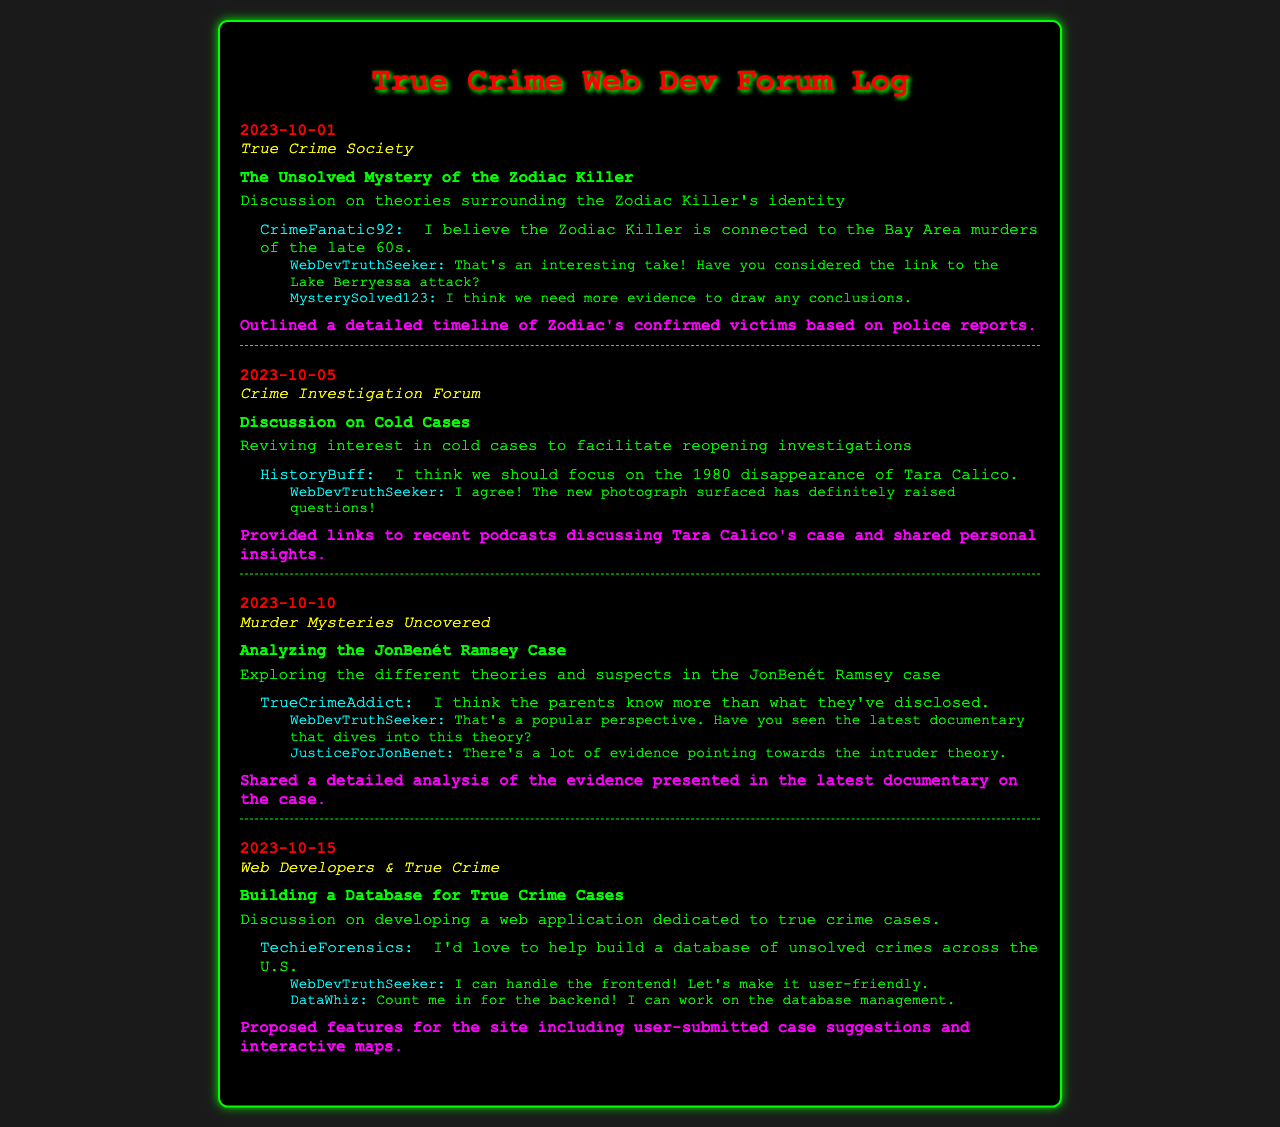What is the date of the first log entry? The first log entry date is stated as "2023-10-01" in the document.
Answer: 2023-10-01 Who contributed to the discussion about the Zodiac Killer? The user interaction shows the contributor as "CrimeFanatic92" who made a comment about the Zodiac Killer's connection.
Answer: CrimeFanatic92 What was the topic of the thread discussed on October 5th? The document mentions the topic as "Reviving interest in cold cases to facilitate reopening investigations."
Answer: Reviving interest in cold cases Which forum had a discussion about building a database for true crime cases? The forum name for this discussion is found in the log entry, specifically titled "Web Developers & True Crime."
Answer: Web Developers & True Crime How many replies did the user "WebDevTruthSeeker" receive in the fourth log entry? The log shows that "WebDevTruthSeeker" received two replies in the fourth log entry.
Answer: 2 What specific case did "HistoryBuff" mention in the cold cases discussion? The mention is made regarding the "1980 disappearance of Tara Calico" in the comment.
Answer: 1980 disappearance of Tara Calico Which user expressed their belief in parental knowledge regarding the JonBenét Ramsey case? The user who made this statement is "TrueCrimeAddict," as mentioned in the comment.
Answer: TrueCrimeAddict What personal contribution did the user make in the Zodiac Killer discussion? The contribution mentioned was "Outlined a detailed timeline of Zodiac's confirmed victims based on police reports."
Answer: Outlined a detailed timeline of Zodiac's confirmed victims What was a proposed feature for the true crime database discussed on October 15th? The specific feature proposed includes "user-submitted case suggestions and interactive maps."
Answer: user-submitted case suggestions and interactive maps 